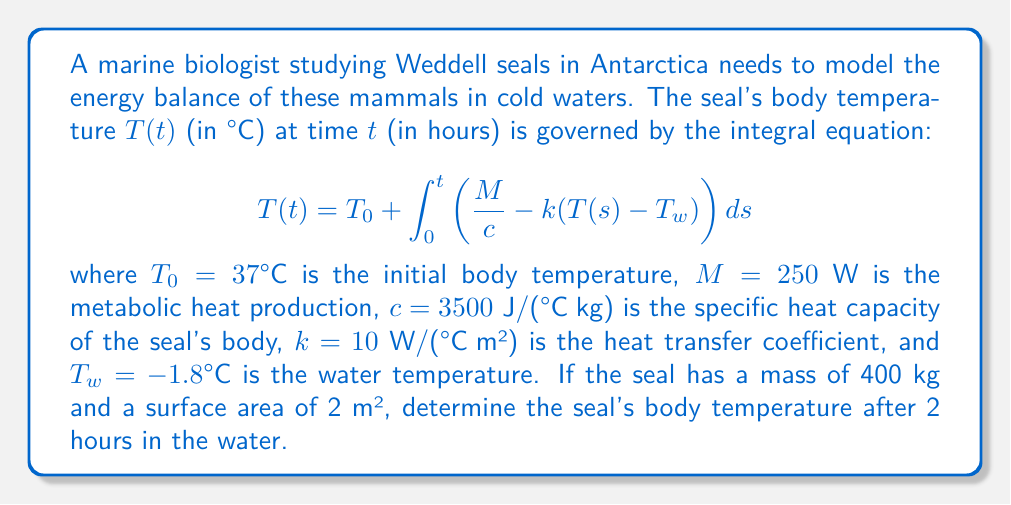Solve this math problem. To solve this problem, we'll follow these steps:

1) First, we need to simplify the integral equation by substituting the given values:

   $$T(t) = 37 + \int_0^t \left(\frac{250}{3500 \cdot 400} - 10 \cdot \frac{2}{3500 \cdot 400}(T(s) - (-1.8))\right) ds$$

2) Simplify the constants:

   $$T(t) = 37 + \int_0^t \left(0.000179 - 0.00001429(T(s) + 1.8)\right) ds$$

3) This is a Volterra integral equation of the second kind. We can solve it numerically using Picard iteration or a numerical method like Euler's method.

4) Using Euler's method with a small time step (e.g., Δt = 0.1 hours):

   For each step: $T(t + \Delta t) = T(t) + \Delta t \cdot (0.000179 - 0.00001429(T(t) + 1.8))$

5) Starting with $T(0) = 37°C$, we iterate 20 times to reach t = 2 hours:

   $T(0.1) = 37 + 0.1 \cdot (0.000179 - 0.00001429(37 + 1.8)) = 36.9999°C$
   $T(0.2) = 36.9999 + 0.1 \cdot (0.000179 - 0.00001429(36.9999 + 1.8)) = 36.9997°C$
   ...
   $T(2.0) ≈ 36.9965°C$

6) Therefore, after 2 hours, the seal's body temperature will be approximately 36.9965°C.
Answer: 36.9965°C 